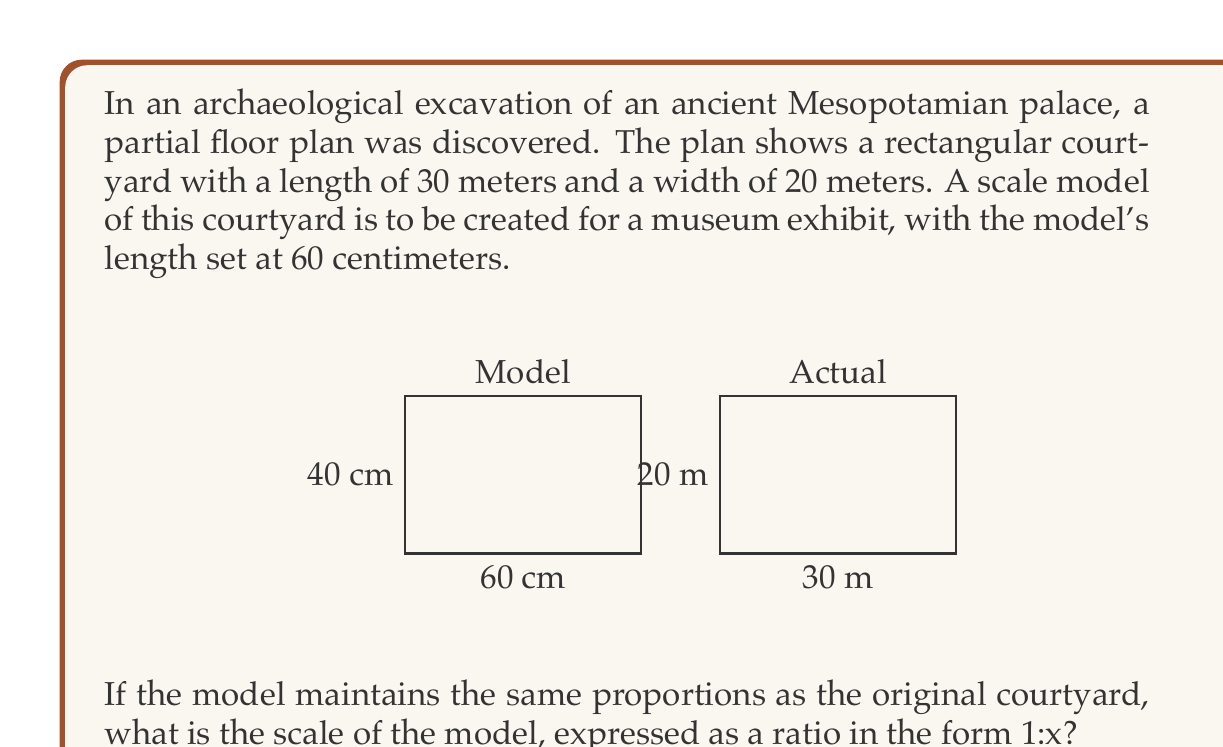Give your solution to this math problem. To determine the scale of the model, we need to compare the dimensions of the model to the actual courtyard. Let's approach this step-by-step:

1) First, let's establish the relationship between the model's length and the actual courtyard's length:
   Model length = 60 cm
   Actual length = 30 m = 3000 cm

2) We can express this as a ratio:
   $\frac{\text{Model length}}{\text{Actual length}} = \frac{60 \text{ cm}}{3000 \text{ cm}} = \frac{1}{50}$

3) This means that every 1 cm in the model represents 50 cm in reality.

4) To express this as a scale in the form 1:x, we need to determine how many centimeters in reality are represented by 1 cm in the model:
   1 cm in model : 50 cm in reality

5) However, scales are typically expressed in whole units (usually meters for larger structures). So we convert 50 cm to 0.5 m:
   1 cm in model : 0.5 m in reality

6) To get a whole number for x, we multiply both sides by 2:
   2 cm in model : 1 m in reality

Therefore, the scale of the model is 1:50, which can be read as "one to fifty" or "one fiftieth".

As a verification, we can check if this scale works for the width:
- Actual width: 20 m
- Model width at 1:50 scale: $20 \text{ m} \div 50 = 0.4 \text{ m} = 40 \text{ cm}$

This matches the proportions of the original courtyard (30m:20m = 3:2, same as 60cm:40cm in the model).
Answer: 1:50 